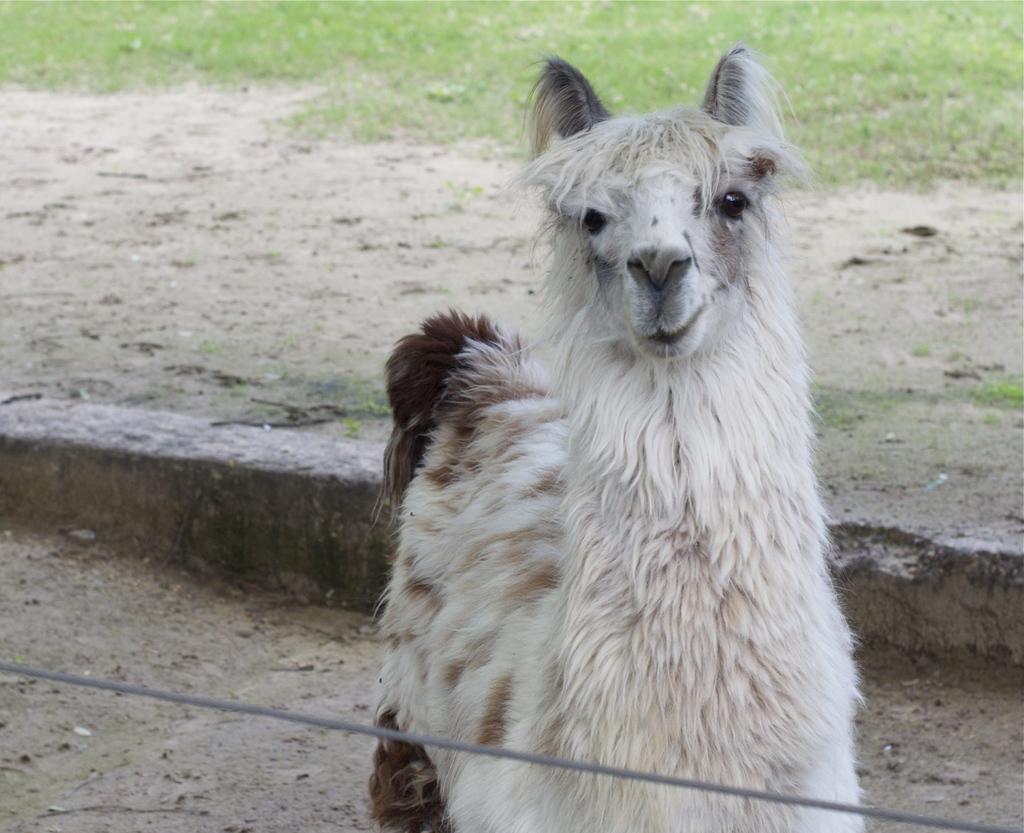Please provide a concise description of this image. In this picture, we see an animal in white color. It looks like a goat. Behind that, we see the stones. At the top of the picture, we see the grass. This picture might be clicked in a zoo. 